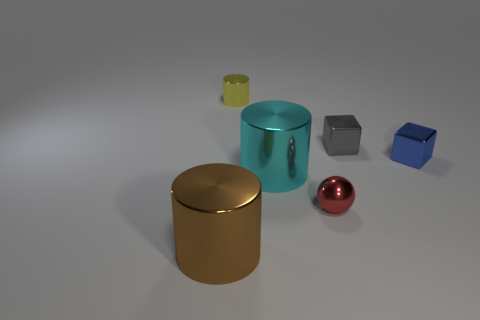Add 2 blue things. How many objects exist? 8 Subtract all spheres. How many objects are left? 5 Add 2 cyan shiny cylinders. How many cyan shiny cylinders are left? 3 Add 4 tiny gray objects. How many tiny gray objects exist? 5 Subtract 0 cyan spheres. How many objects are left? 6 Subtract all small cylinders. Subtract all small things. How many objects are left? 1 